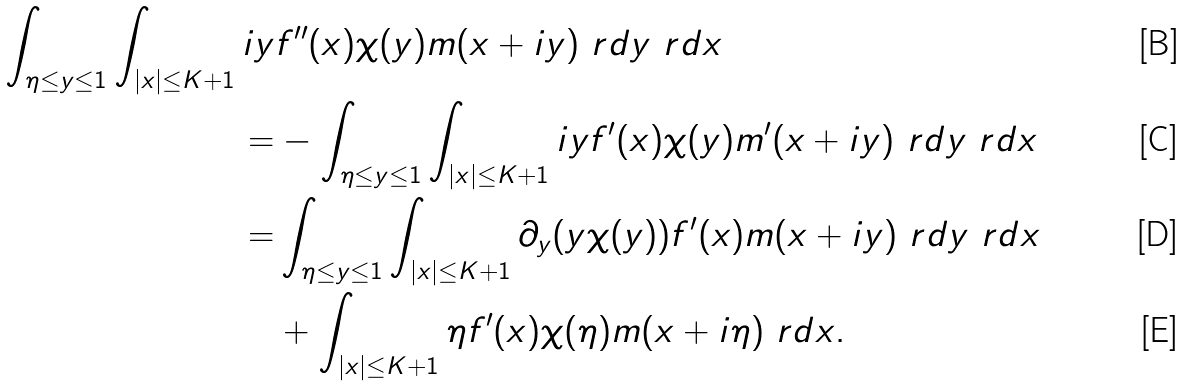<formula> <loc_0><loc_0><loc_500><loc_500>\int _ { \eta \leq y \leq 1 } \int _ { | x | \leq K + 1 } i y & f ^ { \prime \prime } ( x ) \chi ( y ) m ( x + i y ) \ r d y \ r d x \\ = & - \int _ { \eta \leq y \leq 1 } \int _ { | x | \leq K + 1 } i y f ^ { \prime } ( x ) \chi ( y ) m ^ { \prime } ( x + i y ) \ r d y \ r d x \\ = & \int _ { \eta \leq y \leq 1 } \int _ { | x | \leq K + 1 } \partial _ { y } ( y \chi ( y ) ) f ^ { \prime } ( x ) m ( x + i y ) \ r d y \ r d x \\ & + \int _ { | x | \leq K + 1 } \eta f ^ { \prime } ( x ) \chi ( \eta ) m ( x + i \eta ) \ r d x .</formula> 